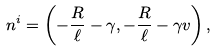<formula> <loc_0><loc_0><loc_500><loc_500>n ^ { i } = \left ( - \frac { R } { \ell } - \gamma , - \frac { R } { \ell } - \gamma v \right ) ,</formula> 